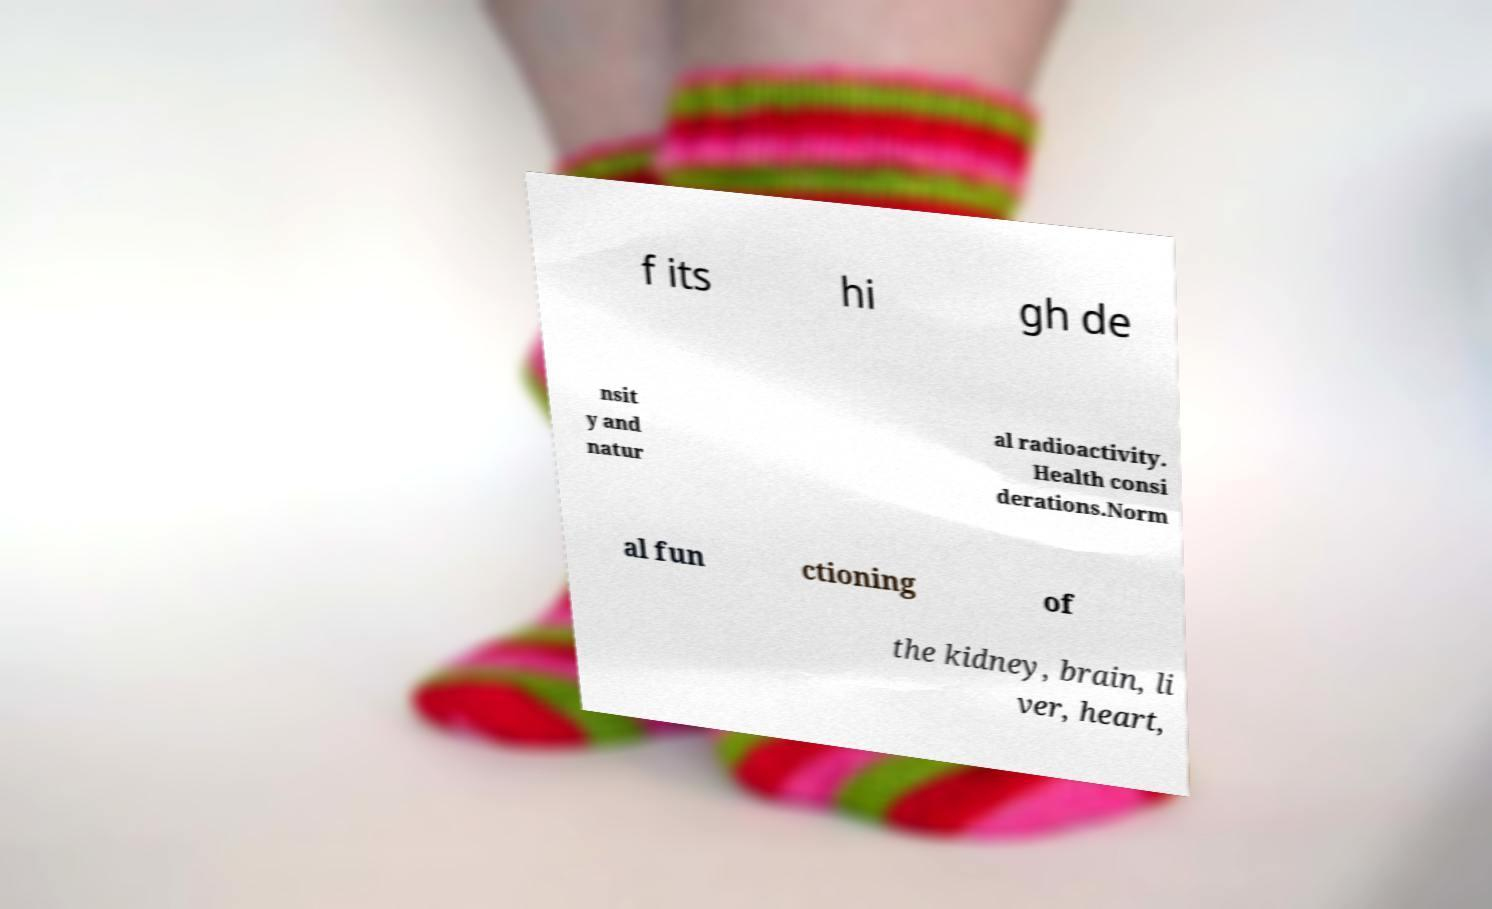Please identify and transcribe the text found in this image. f its hi gh de nsit y and natur al radioactivity. Health consi derations.Norm al fun ctioning of the kidney, brain, li ver, heart, 